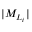Convert formula to latex. <formula><loc_0><loc_0><loc_500><loc_500>| M _ { L _ { i } } |</formula> 